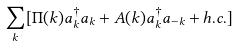Convert formula to latex. <formula><loc_0><loc_0><loc_500><loc_500>\sum _ { k } [ \Pi ( { k } ) a ^ { \dagger } _ { k } a _ { k } + A ( { k } ) a ^ { \dagger } _ { k } a _ { - { k } } + h . c . ]</formula> 